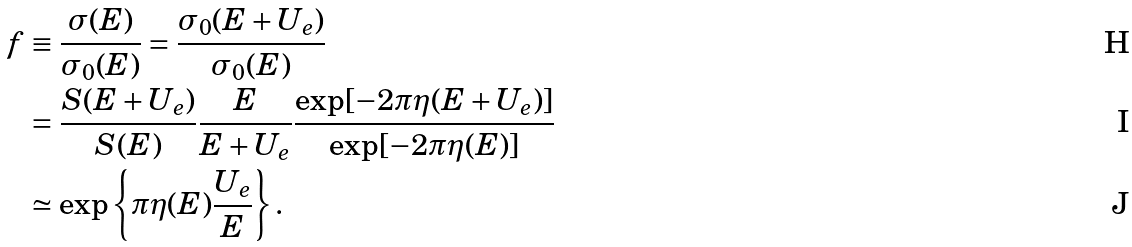<formula> <loc_0><loc_0><loc_500><loc_500>f & \equiv \frac { \sigma ( E ) } { \sigma _ { 0 } ( E ) } = \frac { \sigma _ { 0 } ( E + U _ { e } ) } { \sigma _ { 0 } ( E ) } \\ & = \frac { S ( E + U _ { e } ) } { S ( E ) } \frac { E } { E + U _ { e } } \frac { \exp [ - 2 \pi \eta ( E + U _ { e } ) ] } { \exp [ - 2 \pi \eta ( E ) ] } \\ & \simeq \exp \left \{ \pi \eta ( E ) \frac { U _ { e } } { E } \right \} .</formula> 